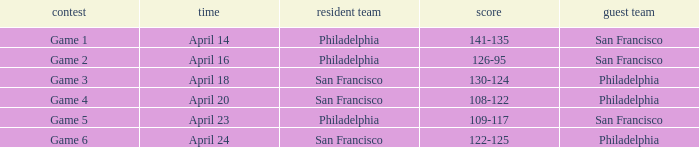Which game had Philadelphia as its home team and was played on April 23? Game 5. 